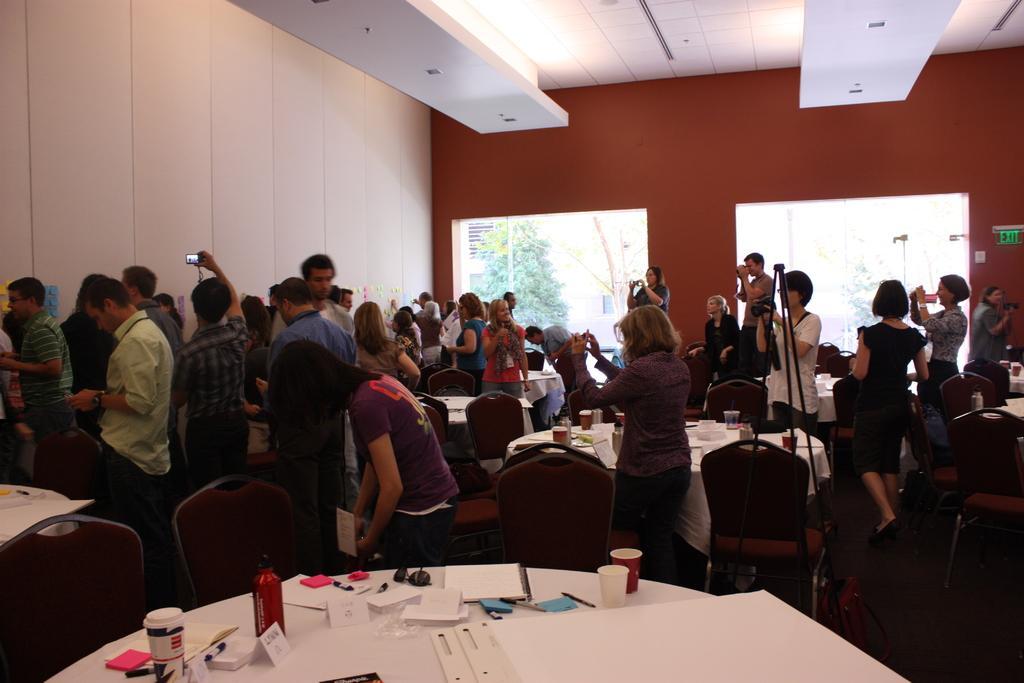Please provide a concise description of this image. in this image i can see table on which there are many papers, cups, bottle. there are many chairs around it. behind that there are many people. at the left there is white color wall. at the right there is orange color wall with two windows and a tree behind 